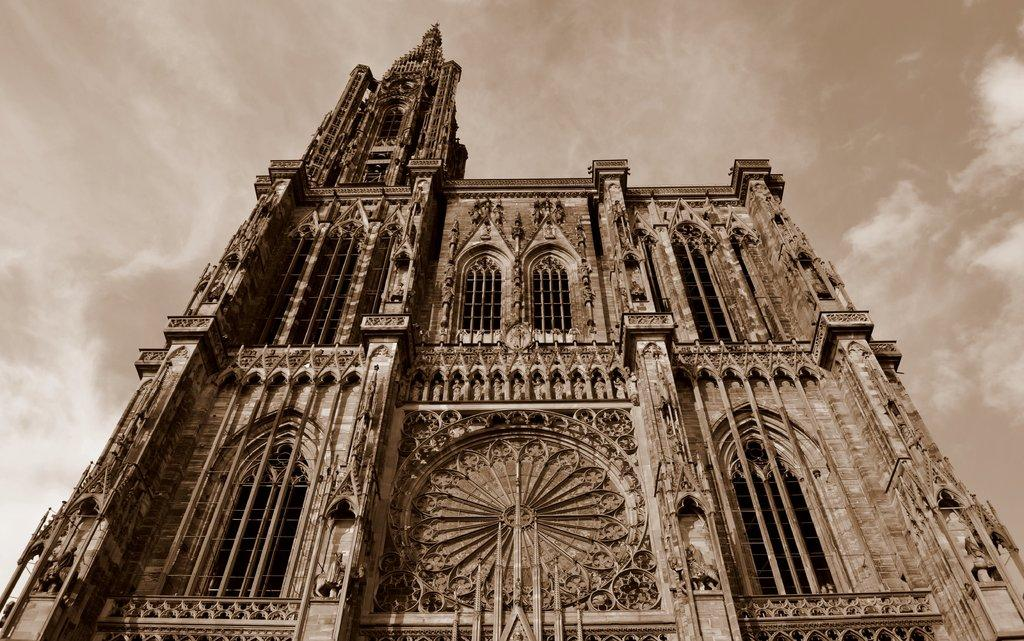What type of structure is visible in the image? There is a fort in the image. What is the condition of the sky in the image? The sky is cloudy in the image. What type of leather is used to cover the feet of the fort in the image? There is no mention of leather or feet in the image, as it features a fort and a cloudy sky. 